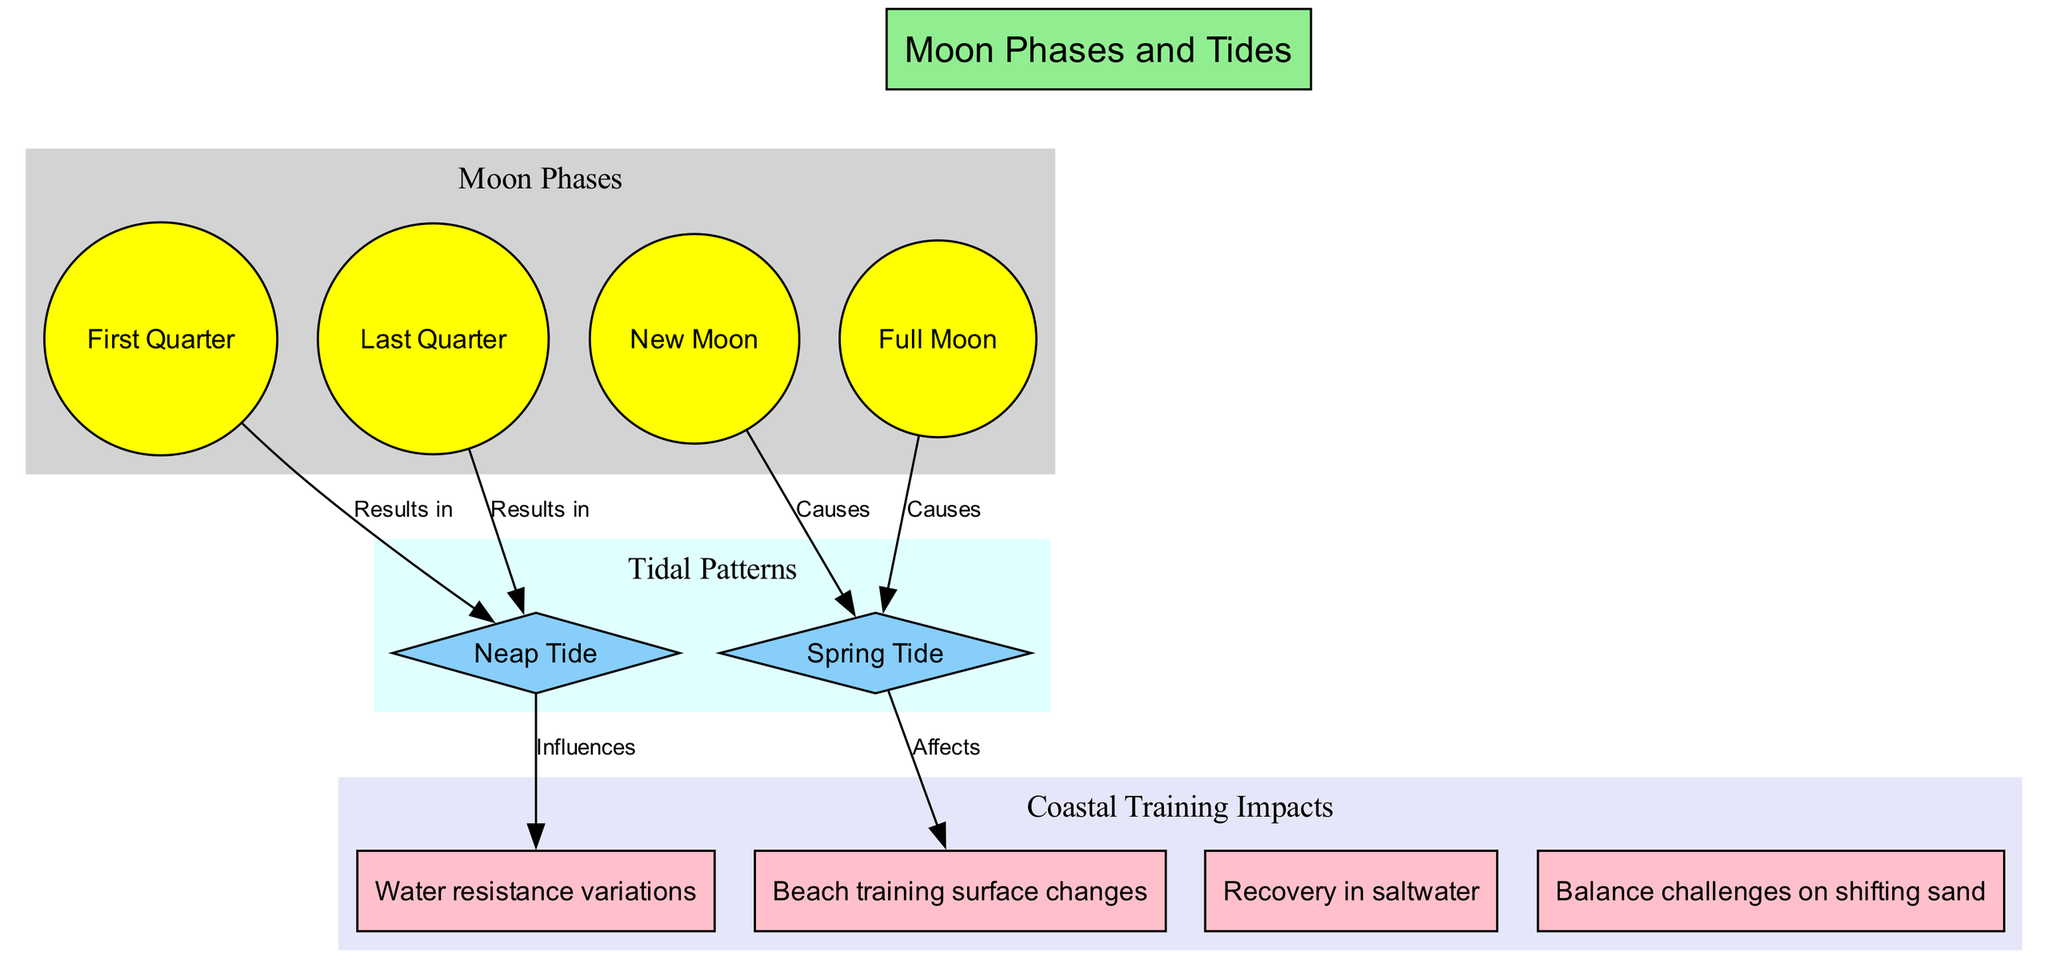What are the four moon phases illustrated? The diagram shows four moon phases: New Moon, First Quarter, Full Moon, and Last Quarter.
Answer: New Moon, First Quarter, Full Moon, Last Quarter Which tidal pattern results from the First Quarter phase? According to the relationships in the diagram, the First Quarter phase results in a Neap Tide.
Answer: Neap Tide How many distinct tidal patterns are displayed in the diagram? The diagram outlines two distinct tidal patterns: Spring Tide and Neap Tide.
Answer: Two What effect do Spring Tides have on beach training surfaces? The diagram indicates that Spring Tides affect beach training surface changes.
Answer: Beach training surface changes Which moon phase directly causes Spring Tide? The diagram specifies that both the New Moon and Full Moon directly cause Spring Tide.
Answer: New Moon and Full Moon How do Neap Tides influence water resistance? The diagram shows that Neap Tides influence water resistance variations.
Answer: Water resistance variations How many relationships are depicted between moon phases and tidal patterns? The diagram illustrates four relationships between moon phases and tidal patterns.
Answer: Four When does the Last Quarter phase occur in relation to tidal patterns? The diagram shows that the Last Quarter phase results in a Neap Tide, indicating a specific relationship in timing between the phases and tides.
Answer: Neap Tide What kind of training challenges arise due to coastal conditions affected by tides? The diagram indicates that balance challenges on shifting sand arise due to coastal conditions influenced by tides.
Answer: Balance challenges on shifting sand 